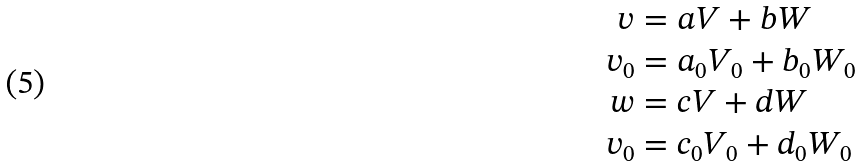Convert formula to latex. <formula><loc_0><loc_0><loc_500><loc_500>v & = a V + b W \\ v _ { 0 } & = a _ { 0 } V _ { 0 } + b _ { 0 } W _ { 0 } \\ w & = c V + d W \\ v _ { 0 } & = c _ { 0 } V _ { 0 } + d _ { 0 } W _ { 0 } \\</formula> 